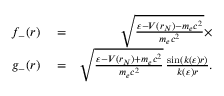<formula> <loc_0><loc_0><loc_500><loc_500>\begin{array} { r l r } { f _ { - } ( r ) } & = } & { \sqrt { \frac { \varepsilon - V ( r _ { N } ) - m _ { e } c ^ { 2 } } { m _ { e } c ^ { 2 } } } \times } \\ { g _ { - } ( r ) } & = } & { \sqrt { \frac { \varepsilon - V ( r _ { N } ) + m _ { e } c ^ { 2 } } { m _ { e } c ^ { 2 } } } \, \frac { \sin ( k ( \varepsilon ) r ) } { k ( \varepsilon ) r } . } \end{array}</formula> 